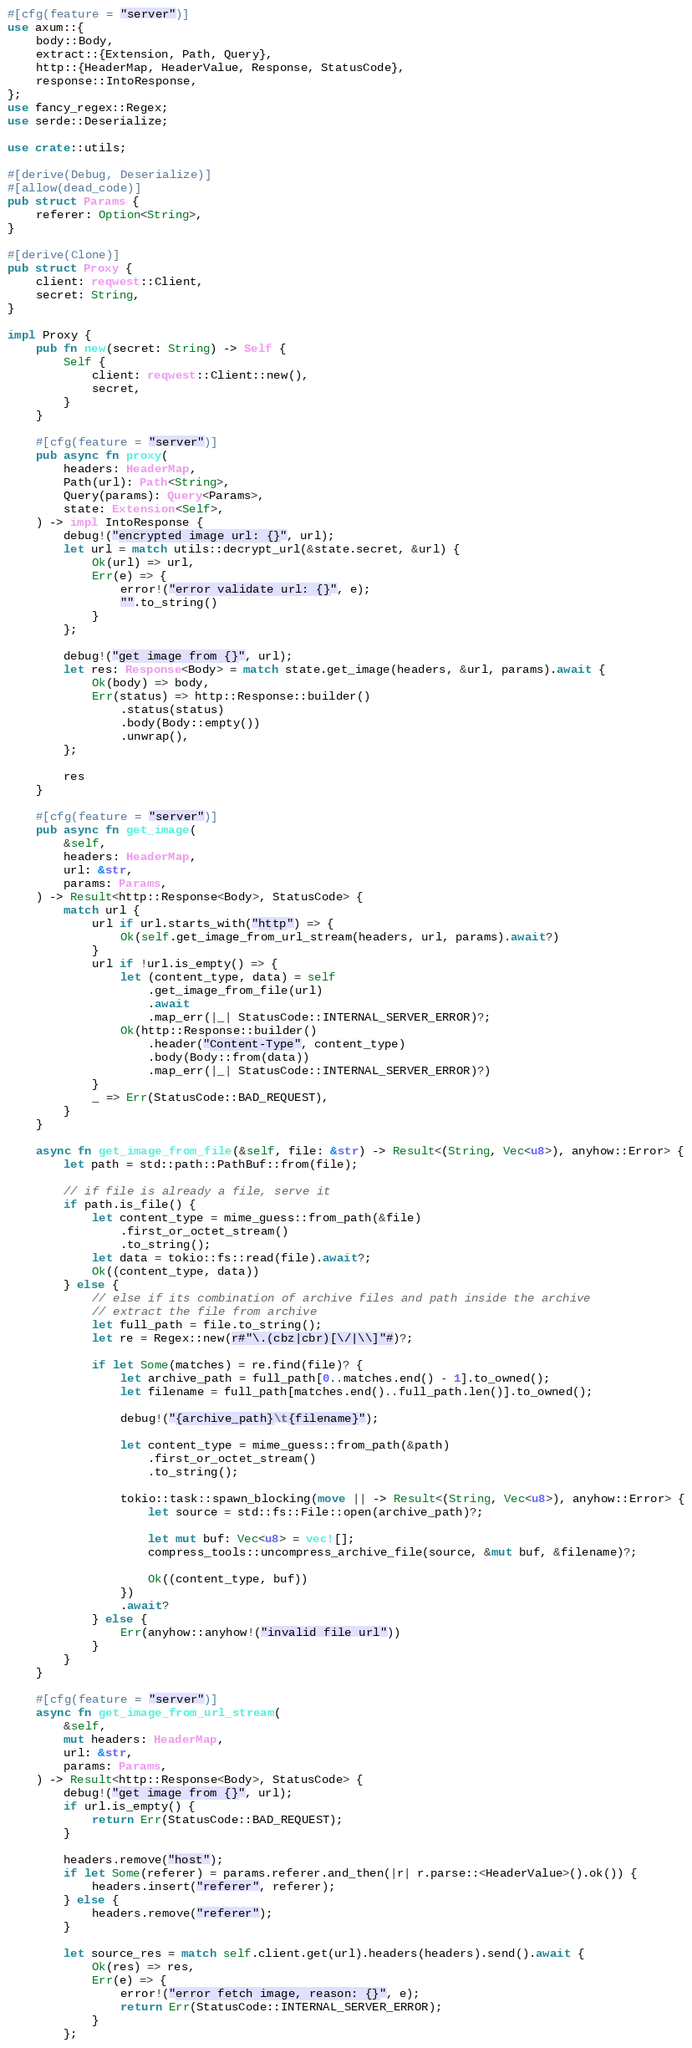Convert code to text. <code><loc_0><loc_0><loc_500><loc_500><_Rust_>#[cfg(feature = "server")]
use axum::{
    body::Body,
    extract::{Extension, Path, Query},
    http::{HeaderMap, HeaderValue, Response, StatusCode},
    response::IntoResponse,
};
use fancy_regex::Regex;
use serde::Deserialize;

use crate::utils;

#[derive(Debug, Deserialize)]
#[allow(dead_code)]
pub struct Params {
    referer: Option<String>,
}

#[derive(Clone)]
pub struct Proxy {
    client: reqwest::Client,
    secret: String,
}

impl Proxy {
    pub fn new(secret: String) -> Self {
        Self {
            client: reqwest::Client::new(),
            secret,
        }
    }

    #[cfg(feature = "server")]
    pub async fn proxy(
        headers: HeaderMap,
        Path(url): Path<String>,
        Query(params): Query<Params>,
        state: Extension<Self>,
    ) -> impl IntoResponse {
        debug!("encrypted image url: {}", url);
        let url = match utils::decrypt_url(&state.secret, &url) {
            Ok(url) => url,
            Err(e) => {
                error!("error validate url: {}", e);
                "".to_string()
            }
        };

        debug!("get image from {}", url);
        let res: Response<Body> = match state.get_image(headers, &url, params).await {
            Ok(body) => body,
            Err(status) => http::Response::builder()
                .status(status)
                .body(Body::empty())
                .unwrap(),
        };

        res
    }

    #[cfg(feature = "server")]
    pub async fn get_image(
        &self,
        headers: HeaderMap,
        url: &str,
        params: Params,
    ) -> Result<http::Response<Body>, StatusCode> {
        match url {
            url if url.starts_with("http") => {
                Ok(self.get_image_from_url_stream(headers, url, params).await?)
            }
            url if !url.is_empty() => {
                let (content_type, data) = self
                    .get_image_from_file(url)
                    .await
                    .map_err(|_| StatusCode::INTERNAL_SERVER_ERROR)?;
                Ok(http::Response::builder()
                    .header("Content-Type", content_type)
                    .body(Body::from(data))
                    .map_err(|_| StatusCode::INTERNAL_SERVER_ERROR)?)
            }
            _ => Err(StatusCode::BAD_REQUEST),
        }
    }

    async fn get_image_from_file(&self, file: &str) -> Result<(String, Vec<u8>), anyhow::Error> {
        let path = std::path::PathBuf::from(file);

        // if file is already a file, serve it
        if path.is_file() {
            let content_type = mime_guess::from_path(&file)
                .first_or_octet_stream()
                .to_string();
            let data = tokio::fs::read(file).await?;
            Ok((content_type, data))
        } else {
            // else if its combination of archive files and path inside the archive
            // extract the file from archive
            let full_path = file.to_string();
            let re = Regex::new(r#"\.(cbz|cbr)[\/|\\]"#)?;

            if let Some(matches) = re.find(file)? {
                let archive_path = full_path[0..matches.end() - 1].to_owned();
                let filename = full_path[matches.end()..full_path.len()].to_owned();

                debug!("{archive_path}\t{filename}");

                let content_type = mime_guess::from_path(&path)
                    .first_or_octet_stream()
                    .to_string();

                tokio::task::spawn_blocking(move || -> Result<(String, Vec<u8>), anyhow::Error> {
                    let source = std::fs::File::open(archive_path)?;

                    let mut buf: Vec<u8> = vec![];
                    compress_tools::uncompress_archive_file(source, &mut buf, &filename)?;

                    Ok((content_type, buf))
                })
                .await?
            } else {
                Err(anyhow::anyhow!("invalid file url"))
            }
        }
    }

    #[cfg(feature = "server")]
    async fn get_image_from_url_stream(
        &self,
        mut headers: HeaderMap,
        url: &str,
        params: Params,
    ) -> Result<http::Response<Body>, StatusCode> {
        debug!("get image from {}", url);
        if url.is_empty() {
            return Err(StatusCode::BAD_REQUEST);
        }

        headers.remove("host");
        if let Some(referer) = params.referer.and_then(|r| r.parse::<HeaderValue>().ok()) {
            headers.insert("referer", referer);
        } else {
            headers.remove("referer");
        }

        let source_res = match self.client.get(url).headers(headers).send().await {
            Ok(res) => res,
            Err(e) => {
                error!("error fetch image, reason: {}", e);
                return Err(StatusCode::INTERNAL_SERVER_ERROR);
            }
        };
</code> 